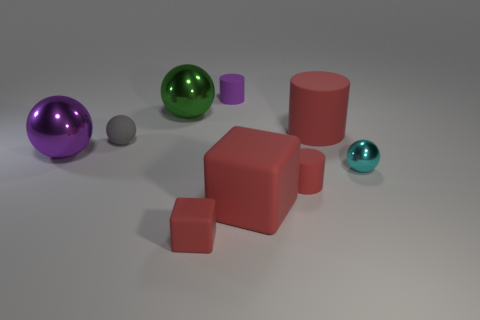Is the thing behind the big green object made of the same material as the tiny cylinder that is in front of the small metal object?
Provide a succinct answer. Yes. There is a big thing that is the same color as the large rubber cube; what is it made of?
Provide a succinct answer. Rubber. How many small red objects are the same shape as the purple matte thing?
Make the answer very short. 1. Are there more red matte cylinders to the left of the green ball than small brown metallic cylinders?
Your response must be concise. No. There is a big matte thing that is to the right of the cylinder that is in front of the shiny ball right of the large cylinder; what is its shape?
Offer a very short reply. Cylinder. Do the red thing behind the tiny metal sphere and the large red object that is in front of the tiny shiny thing have the same shape?
Your answer should be compact. No. How many cylinders are either big matte objects or tiny purple matte things?
Make the answer very short. 2. Are the large purple ball and the small gray object made of the same material?
Your response must be concise. No. What number of other objects are the same color as the large cylinder?
Your answer should be compact. 3. What shape is the purple object in front of the small purple thing?
Provide a succinct answer. Sphere. 